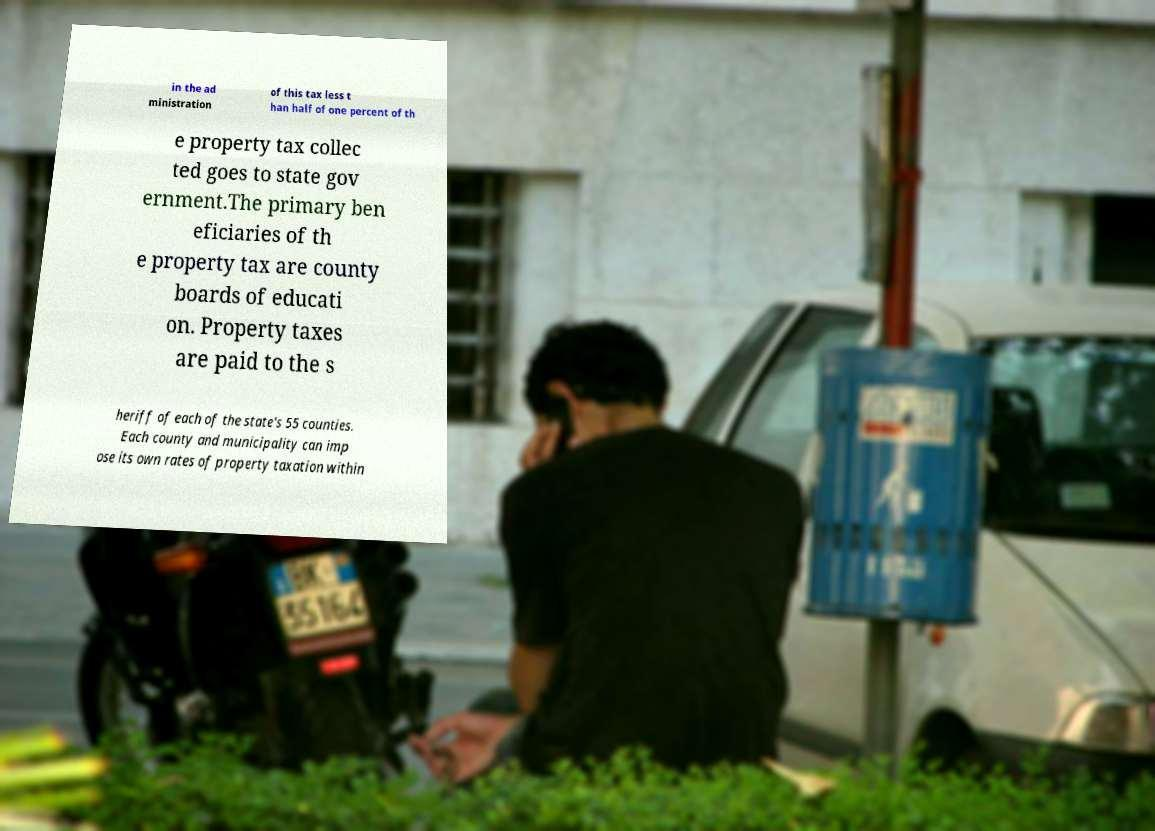Can you read and provide the text displayed in the image?This photo seems to have some interesting text. Can you extract and type it out for me? in the ad ministration of this tax less t han half of one percent of th e property tax collec ted goes to state gov ernment.The primary ben eficiaries of th e property tax are county boards of educati on. Property taxes are paid to the s heriff of each of the state's 55 counties. Each county and municipality can imp ose its own rates of property taxation within 